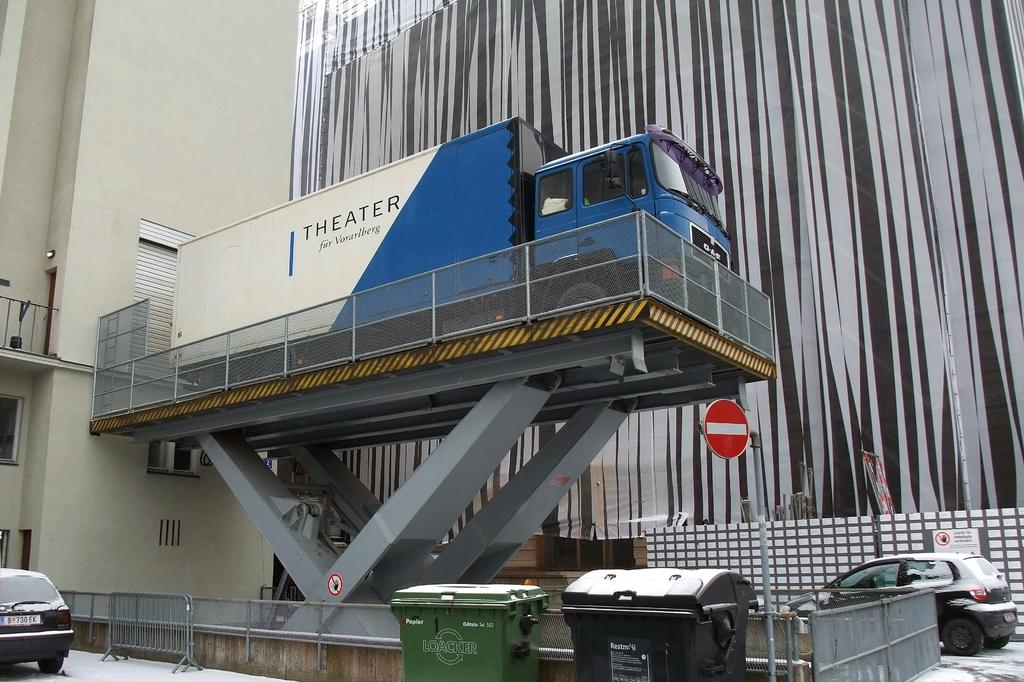<image>
Write a terse but informative summary of the picture. A large blue Theater truck that's on a lift. 